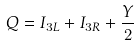Convert formula to latex. <formula><loc_0><loc_0><loc_500><loc_500>Q = I _ { 3 L } + I _ { 3 R } + \frac { Y } { 2 }</formula> 